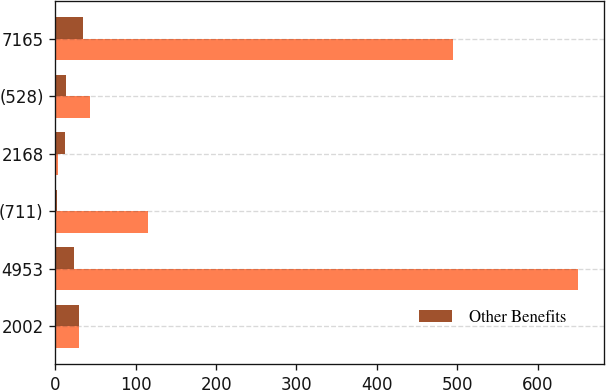Convert chart to OTSL. <chart><loc_0><loc_0><loc_500><loc_500><stacked_bar_chart><ecel><fcel>2002<fcel>4953<fcel>(711)<fcel>2168<fcel>(528)<fcel>7165<nl><fcel>nan<fcel>29.05<fcel>650.6<fcel>115.7<fcel>3<fcel>42.6<fcel>495.3<nl><fcel>Other Benefits<fcel>29.05<fcel>23.7<fcel>2.4<fcel>12<fcel>13<fcel>34.4<nl></chart> 